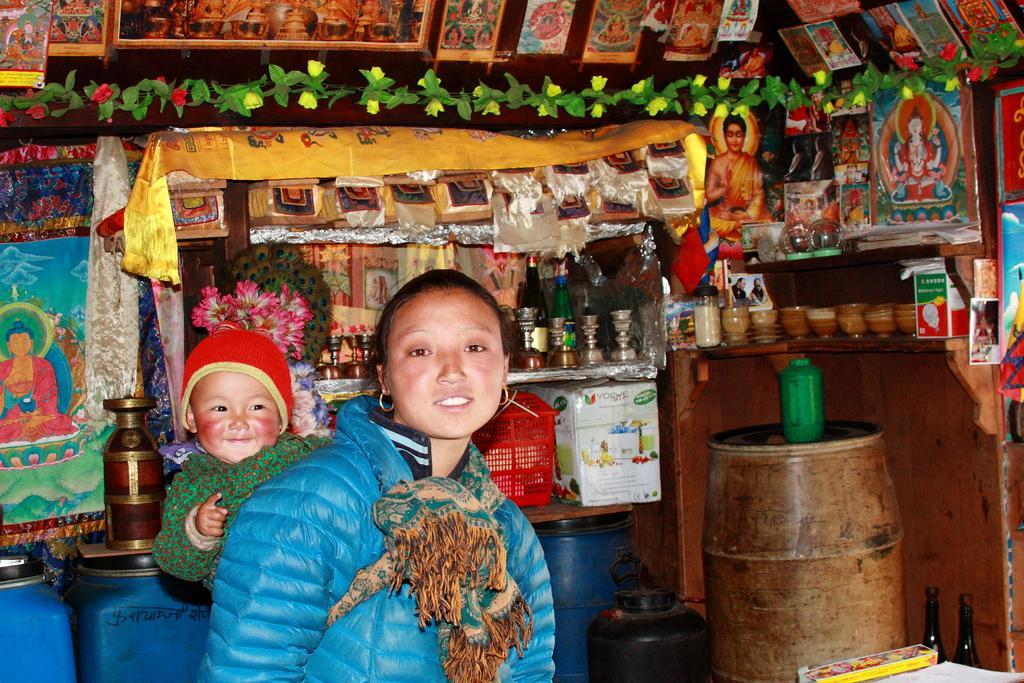How would you summarize this image in a sentence or two? In the center of the image we can see a lady and a baby. On the right there is a drum. In the background there is a shelf and we can see cups and some things placed in the shelf. On the left we can see a vase. At the bottom there are containers. At the top there are decors and photo frames. 